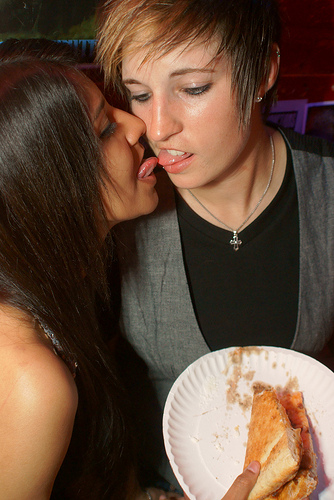<image>
Can you confirm if the pizza is under the kiss? Yes. The pizza is positioned underneath the kiss, with the kiss above it in the vertical space. 